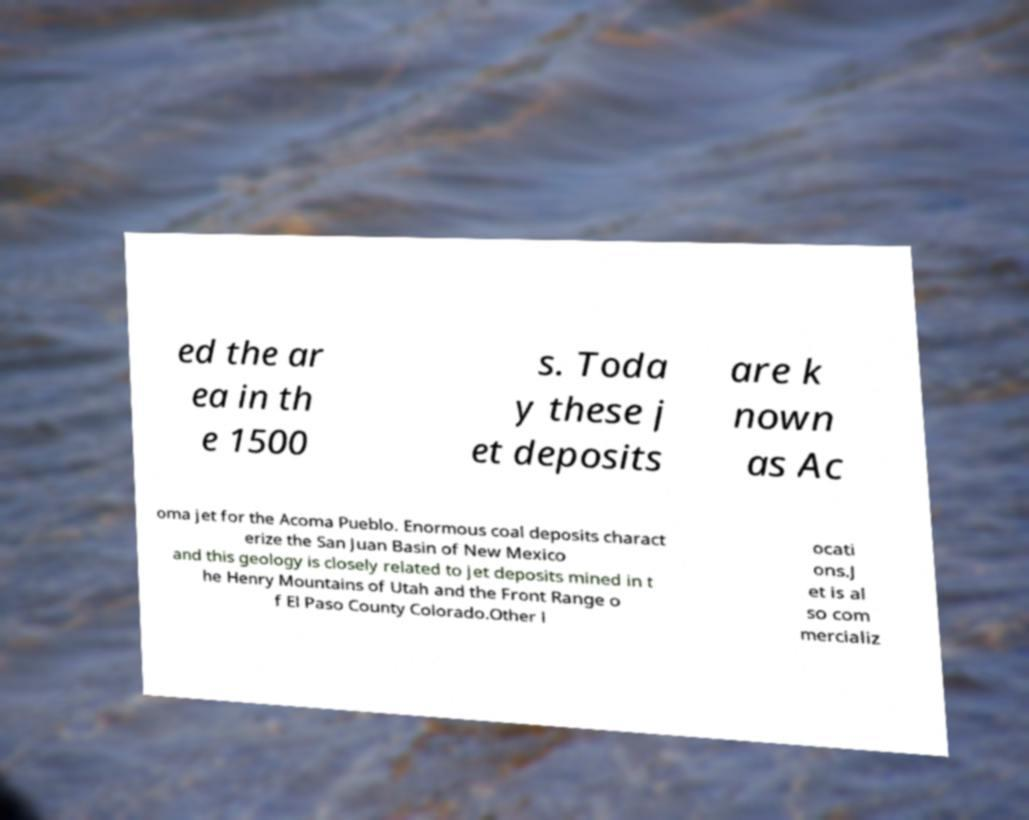Could you assist in decoding the text presented in this image and type it out clearly? ed the ar ea in th e 1500 s. Toda y these j et deposits are k nown as Ac oma jet for the Acoma Pueblo. Enormous coal deposits charact erize the San Juan Basin of New Mexico and this geology is closely related to jet deposits mined in t he Henry Mountains of Utah and the Front Range o f El Paso County Colorado.Other l ocati ons.J et is al so com mercializ 